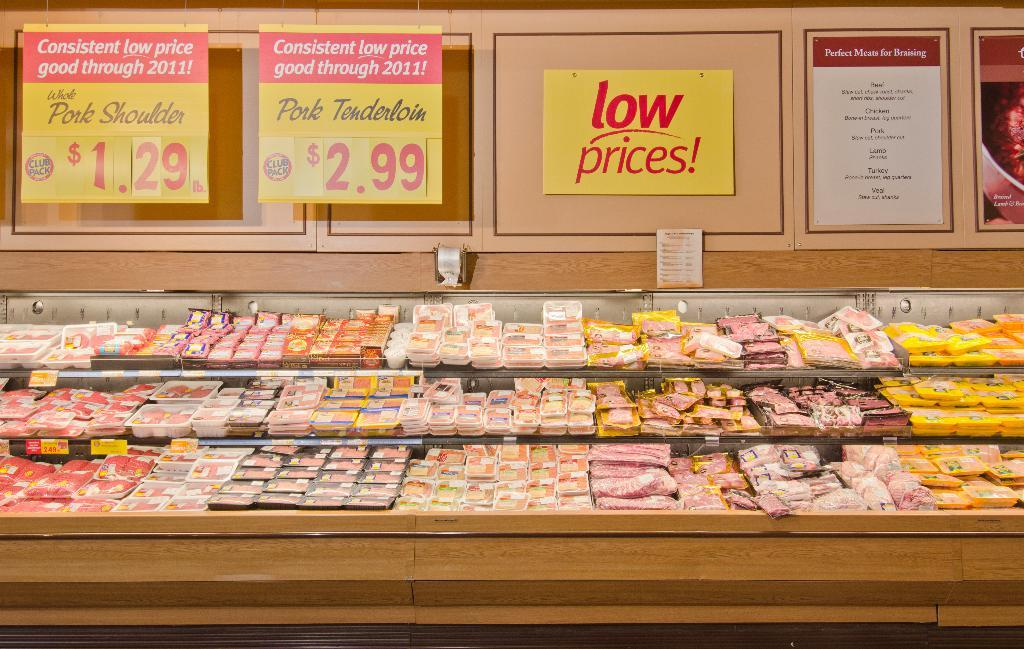<image>
Render a clear and concise summary of the photo. Meat packages in 3 tiered display under yellow and red signs for low prices and good prices on pork shoulder and tenderloin 